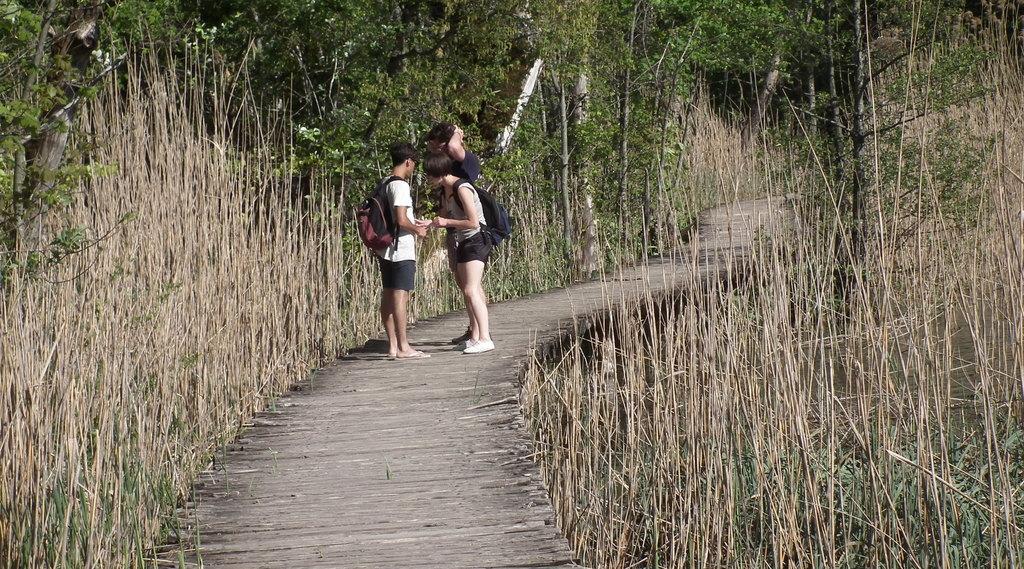Could you give a brief overview of what you see in this image? Here we can see three persons. This is grass. In the background there are trees. 